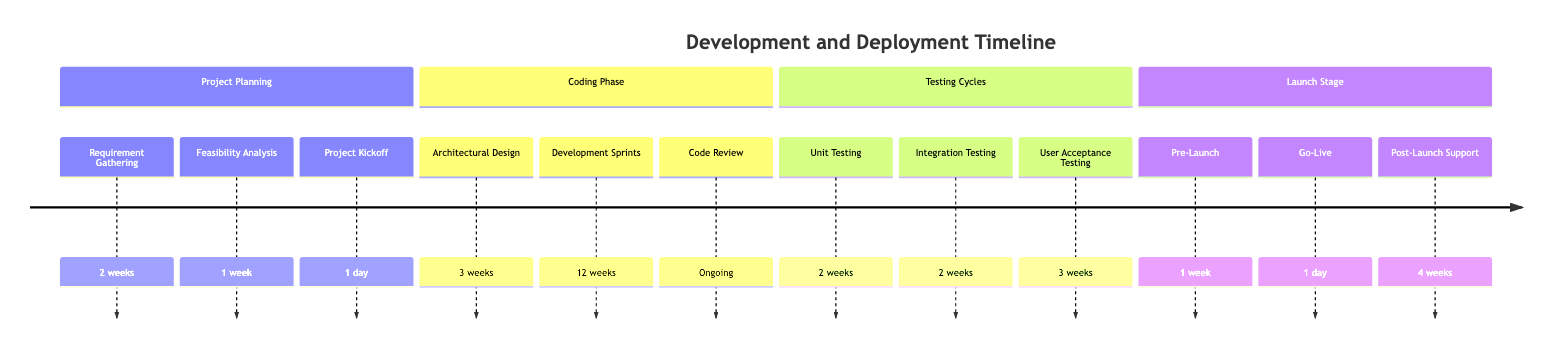What is the duration of the Requirement Gathering phase? The diagram indicates that the Requirement Gathering phase lasts for 2 weeks.
Answer: 2 weeks What is the total duration of the Coding Phase? Adding together the Architectural Design (3 weeks) and Development Sprints (12 weeks), the total for the Coding Phase is 15 weeks.
Answer: 15 weeks How many weeks are allocated for User Acceptance Testing? The diagram specifies that User Acceptance Testing spans 3 weeks.
Answer: 3 weeks What is the last phase before Launch Stage? The last phase listed before Launch Stage in the diagram is Testing Cycles.
Answer: Testing Cycles What is the duration of Post-Launch Support? According to the diagram, Post-Launch Support is scheduled for 4 weeks.
Answer: 4 weeks What phase includes ongoing code reviews? The Coding Phase includes ongoing code reviews as part of its elements.
Answer: Coding Phase What is the duration of the Go-Live event? The diagram states that the Go-Live event lasts for 1 day.
Answer: 1 day Which testing cycle ensures modules work together? Integration Testing ensures that different modules work together as expected.
Answer: Integration Testing What is the duration of the entire project planning phase? The total duration for the project planning phase combines Requirement Gathering (2 weeks), Feasibility Analysis (1 week), and Project Kickoff (1 day), resulting in 3 weeks and 1 day.
Answer: 3 weeks and 1 day 